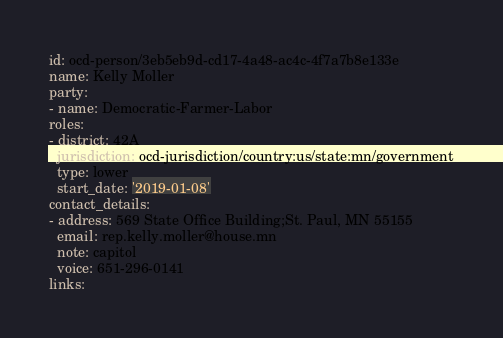<code> <loc_0><loc_0><loc_500><loc_500><_YAML_>id: ocd-person/3eb5eb9d-cd17-4a48-ac4c-4f7a7b8e133e
name: Kelly Moller
party:
- name: Democratic-Farmer-Labor
roles:
- district: 42A
  jurisdiction: ocd-jurisdiction/country:us/state:mn/government
  type: lower
  start_date: '2019-01-08'
contact_details:
- address: 569 State Office Building;St. Paul, MN 55155
  email: rep.kelly.moller@house.mn
  note: capitol
  voice: 651-296-0141
links:</code> 